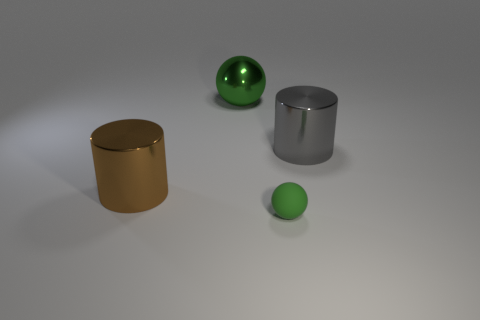Add 3 rubber objects. How many objects exist? 7 Add 3 big green balls. How many big green balls exist? 4 Subtract 0 red cubes. How many objects are left? 4 Subtract all small cyan cylinders. Subtract all large gray metallic things. How many objects are left? 3 Add 4 green objects. How many green objects are left? 6 